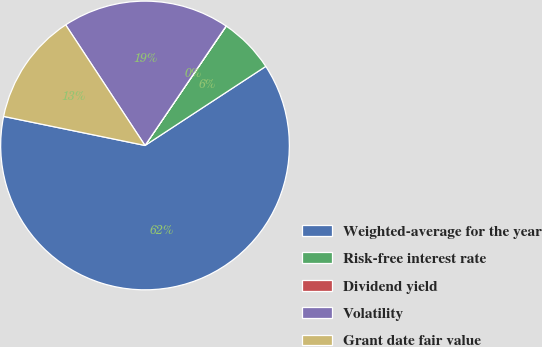Convert chart to OTSL. <chart><loc_0><loc_0><loc_500><loc_500><pie_chart><fcel>Weighted-average for the year<fcel>Risk-free interest rate<fcel>Dividend yield<fcel>Volatility<fcel>Grant date fair value<nl><fcel>62.45%<fcel>6.26%<fcel>0.02%<fcel>18.75%<fcel>12.51%<nl></chart> 